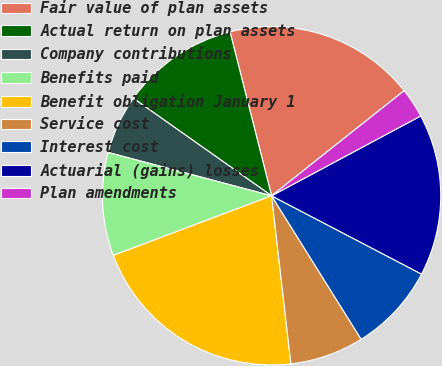Convert chart. <chart><loc_0><loc_0><loc_500><loc_500><pie_chart><fcel>Fair value of plan assets<fcel>Actual return on plan assets<fcel>Company contributions<fcel>Benefits paid<fcel>Benefit obligation January 1<fcel>Service cost<fcel>Interest cost<fcel>Actuarial (gains) losses<fcel>Plan amendments<nl><fcel>18.28%<fcel>11.27%<fcel>5.65%<fcel>9.86%<fcel>21.09%<fcel>7.06%<fcel>8.46%<fcel>15.48%<fcel>2.85%<nl></chart> 